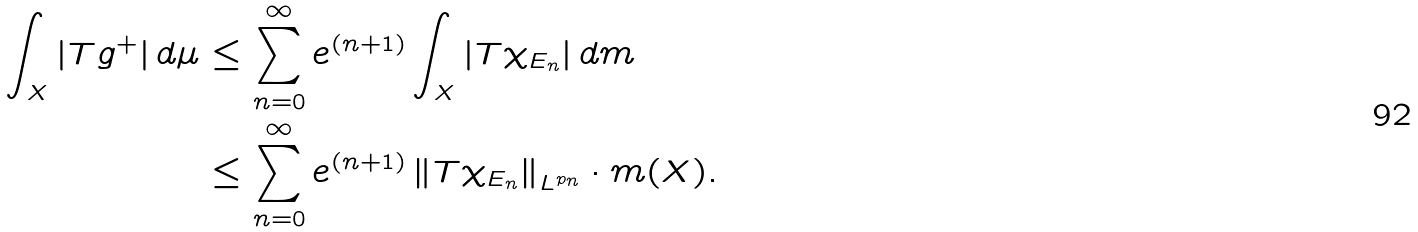<formula> <loc_0><loc_0><loc_500><loc_500>\int _ { X } | T g ^ { + } | \, d \mu & \leq \sum _ { n = 0 } ^ { \infty } e ^ { ( n + 1 ) } \int _ { X } | T \chi _ { E _ { n } } | \, d m \\ & \leq \sum _ { n = 0 } ^ { \infty } e ^ { ( n + 1 ) } \left \| T \chi _ { E _ { n } } \right \| _ { L ^ { p _ { n } } } \cdot m ( X ) .</formula> 